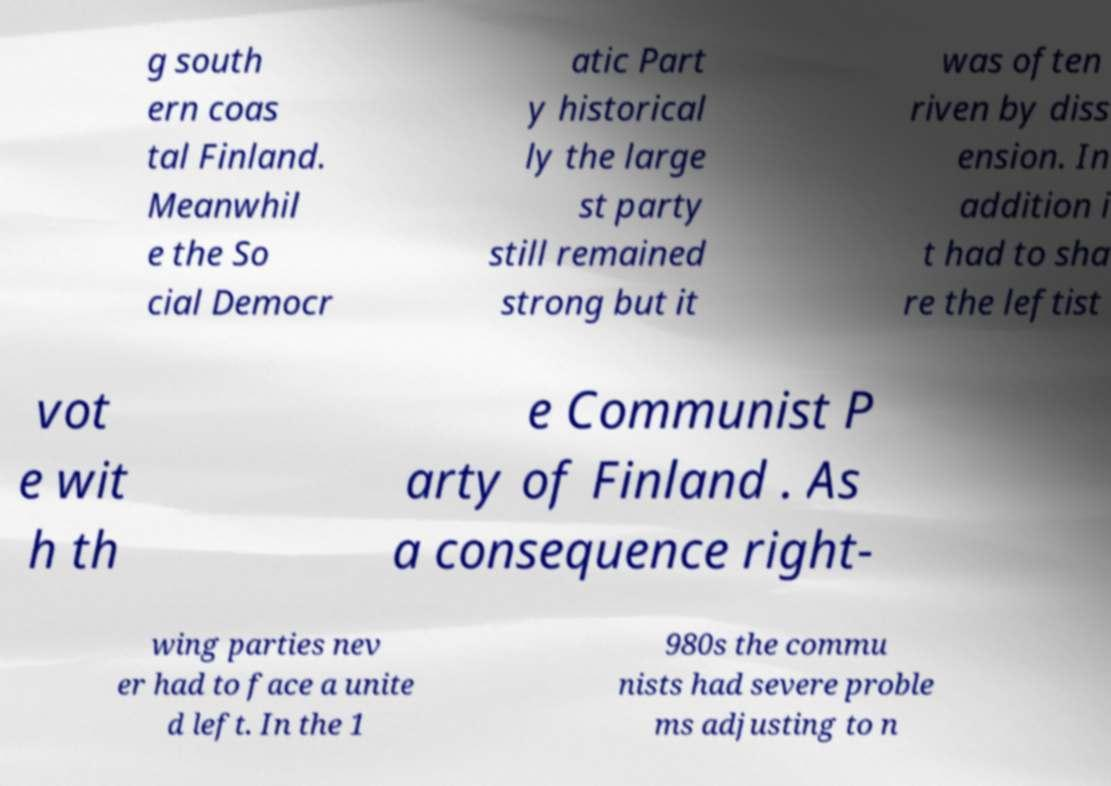Please read and relay the text visible in this image. What does it say? g south ern coas tal Finland. Meanwhil e the So cial Democr atic Part y historical ly the large st party still remained strong but it was often riven by diss ension. In addition i t had to sha re the leftist vot e wit h th e Communist P arty of Finland . As a consequence right- wing parties nev er had to face a unite d left. In the 1 980s the commu nists had severe proble ms adjusting to n 